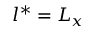<formula> <loc_0><loc_0><loc_500><loc_500>l ^ { * } = L _ { x }</formula> 